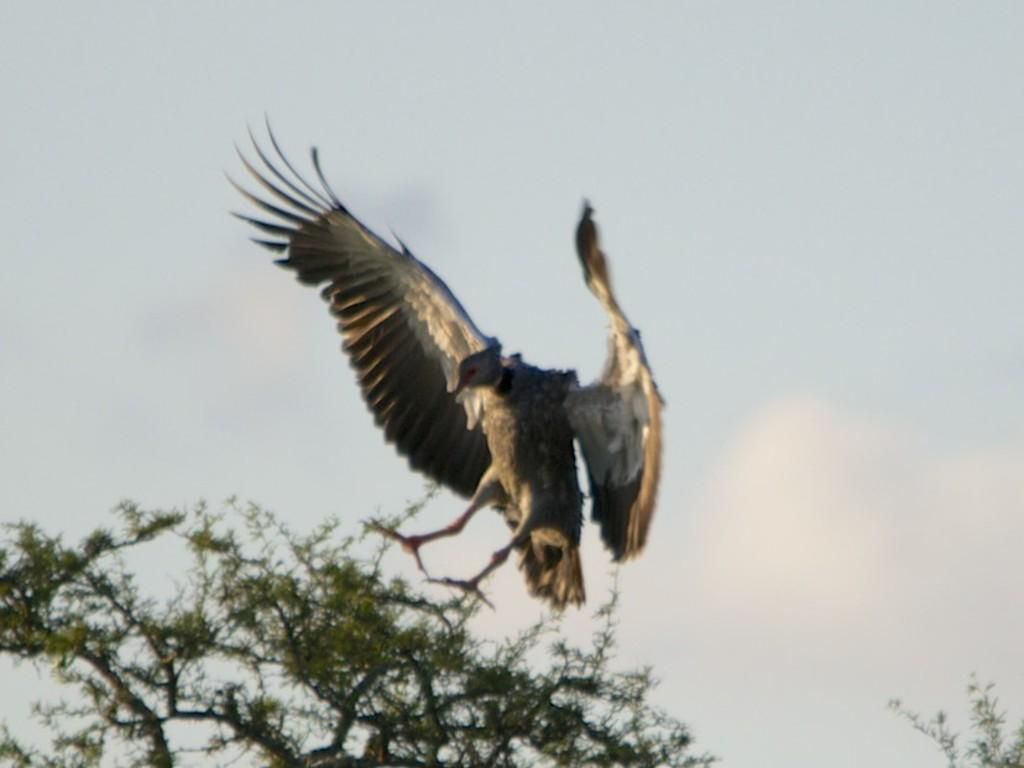What type of vegetation is at the bottom of the image? There are branches with leaves at the bottom of the image. What is happening above the branches? There is a bird flying above the branches. What can be seen at the top of the image? The sky is visible at the top of the image. What type of battle is taking place in the image? There is no battle present in the image; it features branches with leaves, a bird flying above them, and the sky. How does the bird guide the branches in the image? The bird does not guide the branches in the image; it is simply flying above them. 